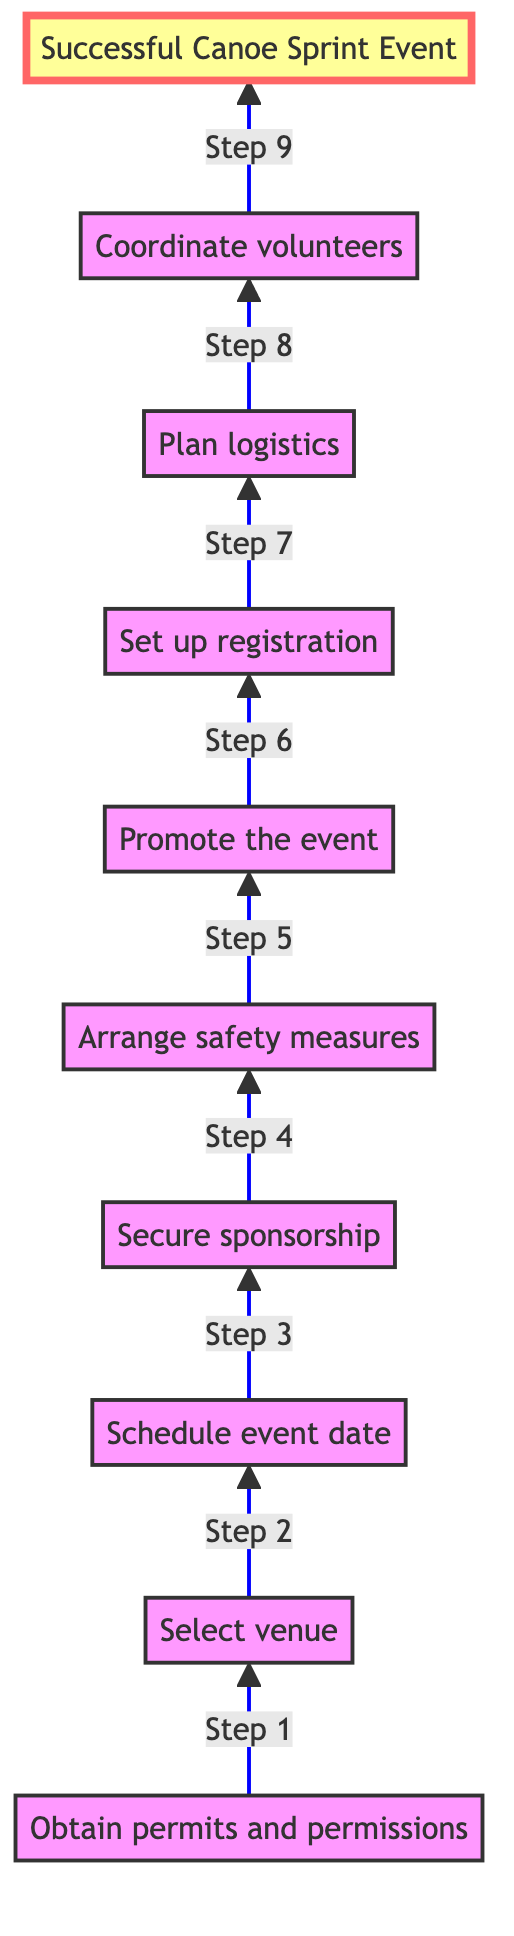What is the first step in organizing a canoe sprint event? The first step, as indicated at the bottom of the flowchart, is "Obtain permits and permissions." This is the initial action required before any further planning can take place.
Answer: Obtain permits and permissions How many steps are there in total in the diagram? Counting each node from "Obtain permits and permissions" to "Successful Canoe Sprint Event," there are a total of 10 steps represented in the flowchart.
Answer: 10 What is the last step in the flowchart? The last step, shown at the top of the flowchart, indicates that the outcome of the process is a "Successful Canoe Sprint Event." This signifies the goal of all preceding actions.
Answer: Successful Canoe Sprint Event Which step comes immediately after "Secure sponsorship"? Following "Secure sponsorship," the next step in the flowchart is "Arrange safety measures." This shows the continuation of the process after obtaining sponsors for the event.
Answer: Arrange safety measures What type of question does the flowchart answer regarding the organization of a canoe sprint event? The flowchart describes the sequence or steps necessary for organizing the event, specifically in a bottom-to-top progression leading to success. Thus, it provides a structured overview of the planning process.
Answer: Steps to organize the event What role do volunteers play in the organization of the event? The diagram indicates that "Coordinate volunteers" is a step towards achieving a successful canoe sprint event. This implies that volunteers are essential for managing event execution.
Answer: Coordinate volunteers Which step directly precedes "Promote the event"? The step that comes just before "Promote the event" is "Arrange safety measures." This highlights that safety preparations must be established before advertising the event to the public.
Answer: Arrange safety measures How is "Schedule event date" related to "Select venue"? "Schedule event date" directly follows "Select venue" in the flowchart, showing that selecting a suitable location is a prerequisite for picking the date of the event.
Answer: Schedule event date What is required before planning logistics? According to the flowchart, "Set up registration" must be completed before "Plan logistics" can begin, indicating that participant management is necessary prior to organizing logistical needs.
Answer: Set up registration 